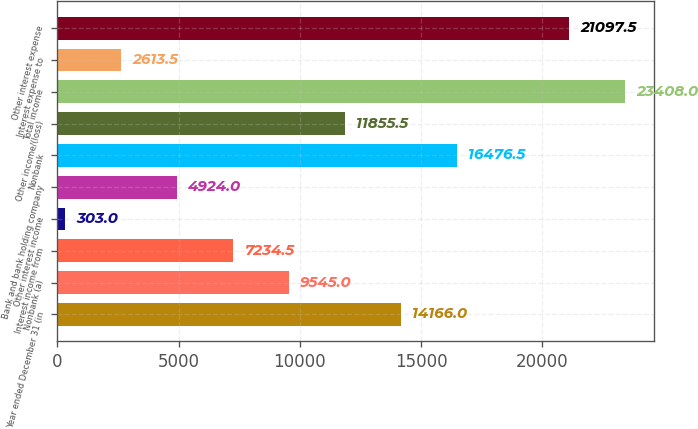Convert chart to OTSL. <chart><loc_0><loc_0><loc_500><loc_500><bar_chart><fcel>Year ended December 31 (in<fcel>Nonbank (a)<fcel>Interest income from<fcel>Other interest income<fcel>Bank and bank holding company<fcel>Nonbank<fcel>Other income/(loss)<fcel>Total income<fcel>Interest expense to<fcel>Other interest expense<nl><fcel>14166<fcel>9545<fcel>7234.5<fcel>303<fcel>4924<fcel>16476.5<fcel>11855.5<fcel>23408<fcel>2613.5<fcel>21097.5<nl></chart> 